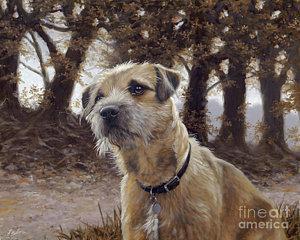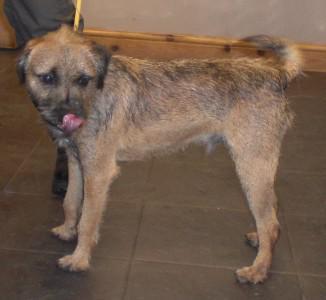The first image is the image on the left, the second image is the image on the right. Considering the images on both sides, is "In one of the two images, the dog is displaying his tongue." valid? Answer yes or no. Yes. 